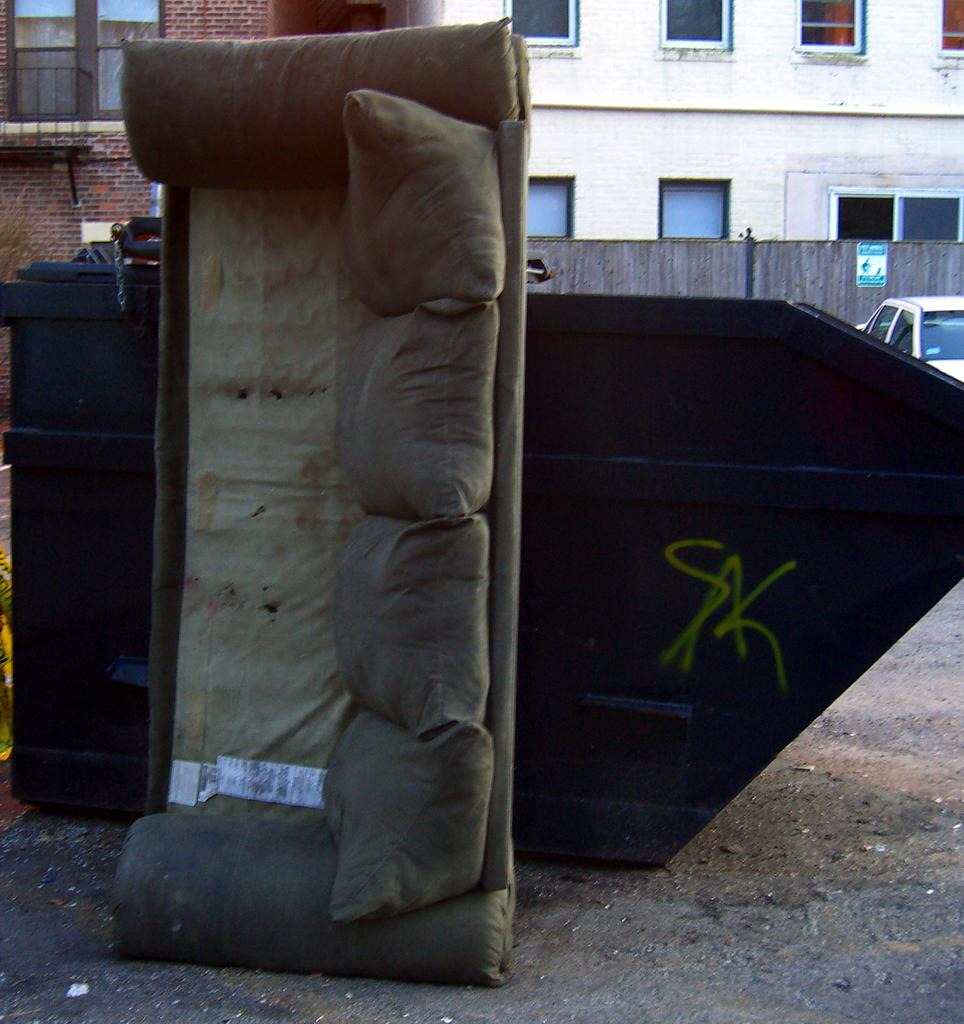What type of furniture is present in the image? There is a sofa in the image. What object can be seen on the ground? There is a container placed on the ground. What can be seen in the background of the image? There is a vehicle, a building with a group of windows, a fence, and a poster with some text in the background. What type of unit is being used to measure the drug in the image? There is no drug or unit present in the image. What is the desire of the person in the image? There is no person present in the image, so it is impossible to determine their desires. 